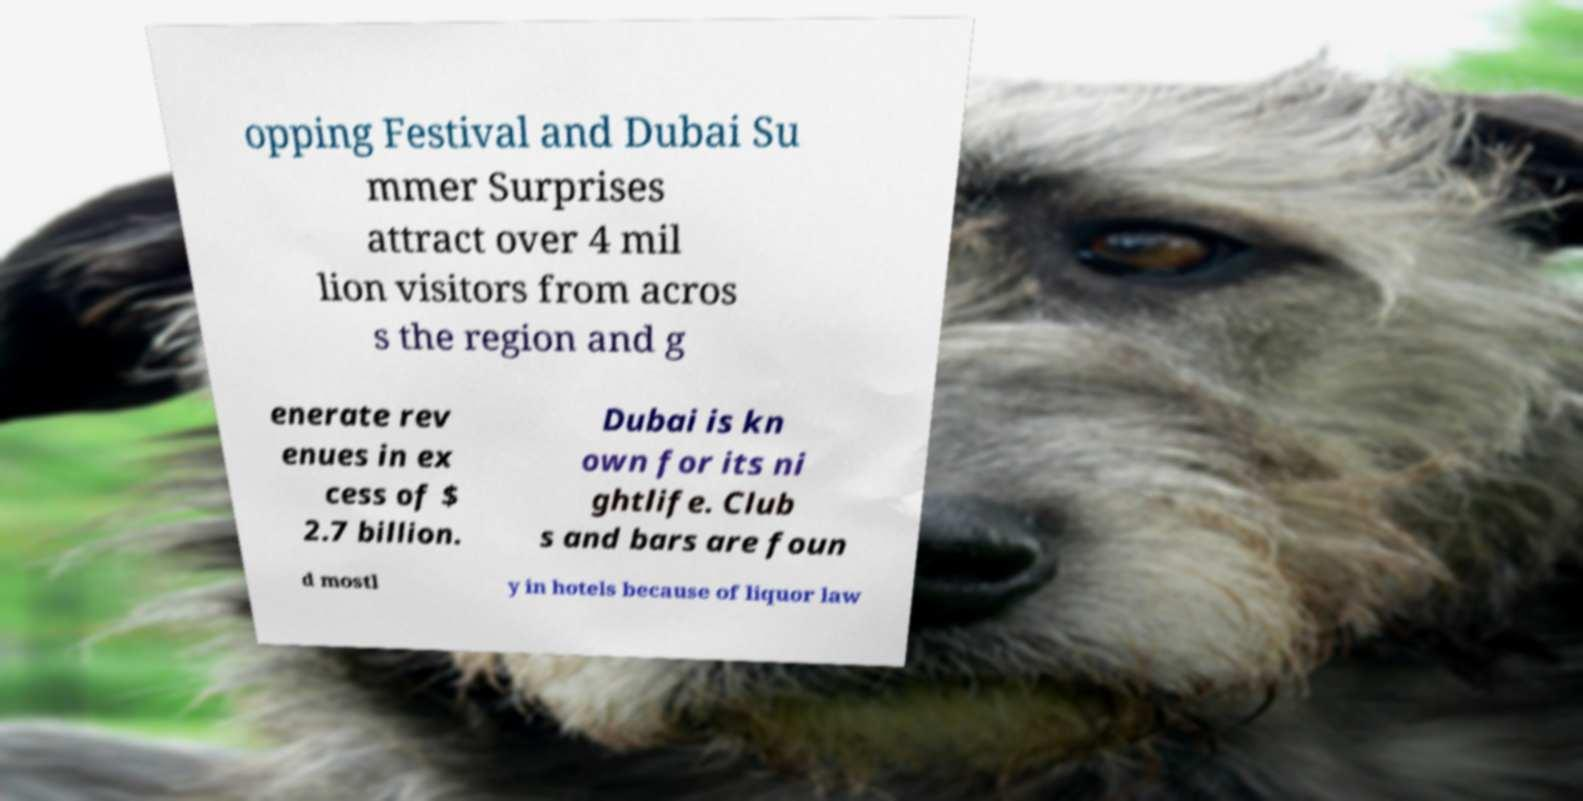Could you extract and type out the text from this image? opping Festival and Dubai Su mmer Surprises attract over 4 mil lion visitors from acros s the region and g enerate rev enues in ex cess of $ 2.7 billion. Dubai is kn own for its ni ghtlife. Club s and bars are foun d mostl y in hotels because of liquor law 